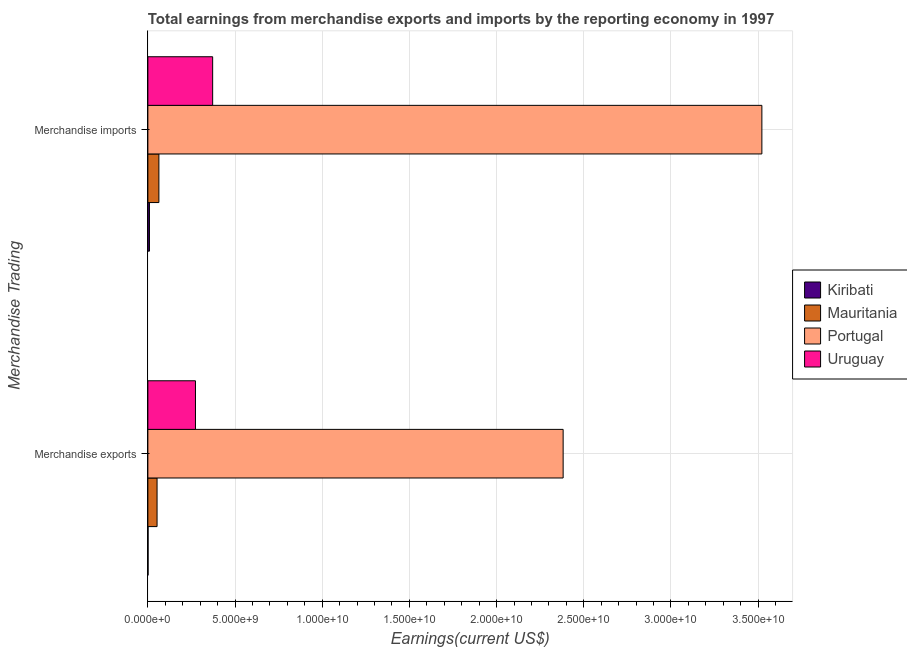Are the number of bars per tick equal to the number of legend labels?
Your answer should be very brief. Yes. Are the number of bars on each tick of the Y-axis equal?
Keep it short and to the point. Yes. How many bars are there on the 1st tick from the top?
Give a very brief answer. 4. What is the earnings from merchandise exports in Portugal?
Your answer should be compact. 2.38e+1. Across all countries, what is the maximum earnings from merchandise imports?
Ensure brevity in your answer.  3.52e+1. Across all countries, what is the minimum earnings from merchandise imports?
Your answer should be very brief. 9.08e+07. In which country was the earnings from merchandise exports minimum?
Keep it short and to the point. Kiribati. What is the total earnings from merchandise imports in the graph?
Keep it short and to the point. 3.97e+1. What is the difference between the earnings from merchandise imports in Kiribati and that in Portugal?
Provide a short and direct response. -3.51e+1. What is the difference between the earnings from merchandise exports in Portugal and the earnings from merchandise imports in Uruguay?
Give a very brief answer. 2.01e+1. What is the average earnings from merchandise exports per country?
Provide a short and direct response. 6.77e+09. What is the difference between the earnings from merchandise imports and earnings from merchandise exports in Portugal?
Your answer should be compact. 1.14e+1. In how many countries, is the earnings from merchandise exports greater than 10000000000 US$?
Your answer should be compact. 1. What is the ratio of the earnings from merchandise imports in Portugal to that in Mauritania?
Offer a very short reply. 55.67. In how many countries, is the earnings from merchandise exports greater than the average earnings from merchandise exports taken over all countries?
Provide a succinct answer. 1. What does the 3rd bar from the top in Merchandise exports represents?
Provide a short and direct response. Mauritania. What does the 4th bar from the bottom in Merchandise exports represents?
Your answer should be compact. Uruguay. How many bars are there?
Give a very brief answer. 8. How many countries are there in the graph?
Make the answer very short. 4. Does the graph contain grids?
Provide a succinct answer. Yes. Where does the legend appear in the graph?
Offer a terse response. Center right. How many legend labels are there?
Ensure brevity in your answer.  4. How are the legend labels stacked?
Provide a short and direct response. Vertical. What is the title of the graph?
Keep it short and to the point. Total earnings from merchandise exports and imports by the reporting economy in 1997. What is the label or title of the X-axis?
Provide a succinct answer. Earnings(current US$). What is the label or title of the Y-axis?
Your answer should be compact. Merchandise Trading. What is the Earnings(current US$) of Kiribati in Merchandise exports?
Offer a terse response. 1.10e+07. What is the Earnings(current US$) in Mauritania in Merchandise exports?
Provide a short and direct response. 5.27e+08. What is the Earnings(current US$) in Portugal in Merchandise exports?
Offer a terse response. 2.38e+1. What is the Earnings(current US$) in Uruguay in Merchandise exports?
Make the answer very short. 2.73e+09. What is the Earnings(current US$) in Kiribati in Merchandise imports?
Your answer should be compact. 9.08e+07. What is the Earnings(current US$) of Mauritania in Merchandise imports?
Provide a succinct answer. 6.33e+08. What is the Earnings(current US$) of Portugal in Merchandise imports?
Your answer should be very brief. 3.52e+1. What is the Earnings(current US$) of Uruguay in Merchandise imports?
Your response must be concise. 3.72e+09. Across all Merchandise Trading, what is the maximum Earnings(current US$) in Kiribati?
Keep it short and to the point. 9.08e+07. Across all Merchandise Trading, what is the maximum Earnings(current US$) of Mauritania?
Your response must be concise. 6.33e+08. Across all Merchandise Trading, what is the maximum Earnings(current US$) of Portugal?
Provide a short and direct response. 3.52e+1. Across all Merchandise Trading, what is the maximum Earnings(current US$) in Uruguay?
Make the answer very short. 3.72e+09. Across all Merchandise Trading, what is the minimum Earnings(current US$) of Kiribati?
Make the answer very short. 1.10e+07. Across all Merchandise Trading, what is the minimum Earnings(current US$) of Mauritania?
Make the answer very short. 5.27e+08. Across all Merchandise Trading, what is the minimum Earnings(current US$) in Portugal?
Your answer should be compact. 2.38e+1. Across all Merchandise Trading, what is the minimum Earnings(current US$) of Uruguay?
Offer a very short reply. 2.73e+09. What is the total Earnings(current US$) of Kiribati in the graph?
Give a very brief answer. 1.02e+08. What is the total Earnings(current US$) in Mauritania in the graph?
Offer a very short reply. 1.16e+09. What is the total Earnings(current US$) of Portugal in the graph?
Offer a terse response. 5.90e+1. What is the total Earnings(current US$) of Uruguay in the graph?
Offer a terse response. 6.44e+09. What is the difference between the Earnings(current US$) in Kiribati in Merchandise exports and that in Merchandise imports?
Offer a terse response. -7.98e+07. What is the difference between the Earnings(current US$) of Mauritania in Merchandise exports and that in Merchandise imports?
Ensure brevity in your answer.  -1.05e+08. What is the difference between the Earnings(current US$) in Portugal in Merchandise exports and that in Merchandise imports?
Give a very brief answer. -1.14e+1. What is the difference between the Earnings(current US$) of Uruguay in Merchandise exports and that in Merchandise imports?
Offer a very short reply. -9.86e+08. What is the difference between the Earnings(current US$) in Kiribati in Merchandise exports and the Earnings(current US$) in Mauritania in Merchandise imports?
Your answer should be compact. -6.22e+08. What is the difference between the Earnings(current US$) of Kiribati in Merchandise exports and the Earnings(current US$) of Portugal in Merchandise imports?
Provide a short and direct response. -3.52e+1. What is the difference between the Earnings(current US$) of Kiribati in Merchandise exports and the Earnings(current US$) of Uruguay in Merchandise imports?
Give a very brief answer. -3.70e+09. What is the difference between the Earnings(current US$) of Mauritania in Merchandise exports and the Earnings(current US$) of Portugal in Merchandise imports?
Keep it short and to the point. -3.47e+1. What is the difference between the Earnings(current US$) of Mauritania in Merchandise exports and the Earnings(current US$) of Uruguay in Merchandise imports?
Your answer should be very brief. -3.19e+09. What is the difference between the Earnings(current US$) in Portugal in Merchandise exports and the Earnings(current US$) in Uruguay in Merchandise imports?
Make the answer very short. 2.01e+1. What is the average Earnings(current US$) of Kiribati per Merchandise Trading?
Offer a very short reply. 5.09e+07. What is the average Earnings(current US$) of Mauritania per Merchandise Trading?
Make the answer very short. 5.80e+08. What is the average Earnings(current US$) in Portugal per Merchandise Trading?
Offer a terse response. 2.95e+1. What is the average Earnings(current US$) in Uruguay per Merchandise Trading?
Provide a succinct answer. 3.22e+09. What is the difference between the Earnings(current US$) of Kiribati and Earnings(current US$) of Mauritania in Merchandise exports?
Make the answer very short. -5.16e+08. What is the difference between the Earnings(current US$) of Kiribati and Earnings(current US$) of Portugal in Merchandise exports?
Your response must be concise. -2.38e+1. What is the difference between the Earnings(current US$) in Kiribati and Earnings(current US$) in Uruguay in Merchandise exports?
Your response must be concise. -2.72e+09. What is the difference between the Earnings(current US$) of Mauritania and Earnings(current US$) of Portugal in Merchandise exports?
Your response must be concise. -2.33e+1. What is the difference between the Earnings(current US$) in Mauritania and Earnings(current US$) in Uruguay in Merchandise exports?
Keep it short and to the point. -2.20e+09. What is the difference between the Earnings(current US$) of Portugal and Earnings(current US$) of Uruguay in Merchandise exports?
Offer a very short reply. 2.11e+1. What is the difference between the Earnings(current US$) in Kiribati and Earnings(current US$) in Mauritania in Merchandise imports?
Offer a terse response. -5.42e+08. What is the difference between the Earnings(current US$) of Kiribati and Earnings(current US$) of Portugal in Merchandise imports?
Your response must be concise. -3.51e+1. What is the difference between the Earnings(current US$) of Kiribati and Earnings(current US$) of Uruguay in Merchandise imports?
Provide a succinct answer. -3.62e+09. What is the difference between the Earnings(current US$) in Mauritania and Earnings(current US$) in Portugal in Merchandise imports?
Your answer should be compact. -3.46e+1. What is the difference between the Earnings(current US$) in Mauritania and Earnings(current US$) in Uruguay in Merchandise imports?
Keep it short and to the point. -3.08e+09. What is the difference between the Earnings(current US$) in Portugal and Earnings(current US$) in Uruguay in Merchandise imports?
Give a very brief answer. 3.15e+1. What is the ratio of the Earnings(current US$) in Kiribati in Merchandise exports to that in Merchandise imports?
Ensure brevity in your answer.  0.12. What is the ratio of the Earnings(current US$) in Portugal in Merchandise exports to that in Merchandise imports?
Give a very brief answer. 0.68. What is the ratio of the Earnings(current US$) in Uruguay in Merchandise exports to that in Merchandise imports?
Ensure brevity in your answer.  0.73. What is the difference between the highest and the second highest Earnings(current US$) in Kiribati?
Offer a terse response. 7.98e+07. What is the difference between the highest and the second highest Earnings(current US$) of Mauritania?
Your answer should be very brief. 1.05e+08. What is the difference between the highest and the second highest Earnings(current US$) of Portugal?
Provide a succinct answer. 1.14e+1. What is the difference between the highest and the second highest Earnings(current US$) of Uruguay?
Provide a succinct answer. 9.86e+08. What is the difference between the highest and the lowest Earnings(current US$) in Kiribati?
Offer a terse response. 7.98e+07. What is the difference between the highest and the lowest Earnings(current US$) in Mauritania?
Offer a very short reply. 1.05e+08. What is the difference between the highest and the lowest Earnings(current US$) of Portugal?
Keep it short and to the point. 1.14e+1. What is the difference between the highest and the lowest Earnings(current US$) in Uruguay?
Provide a short and direct response. 9.86e+08. 